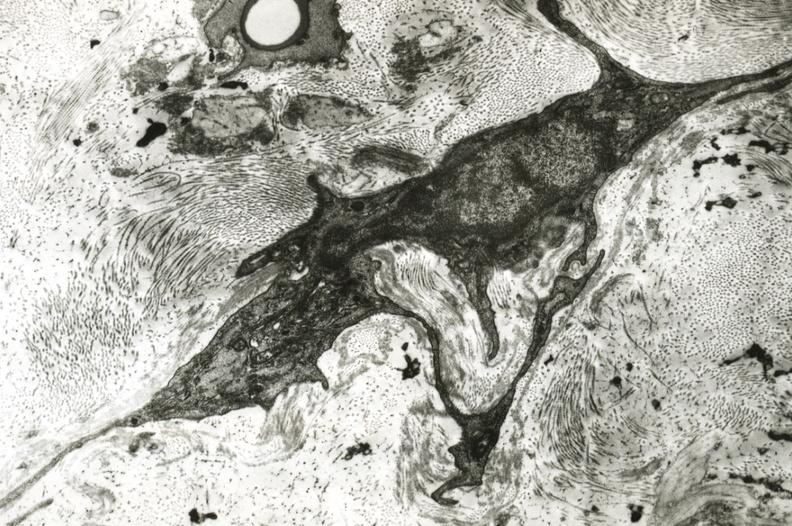s vasculature present?
Answer the question using a single word or phrase. Yes 